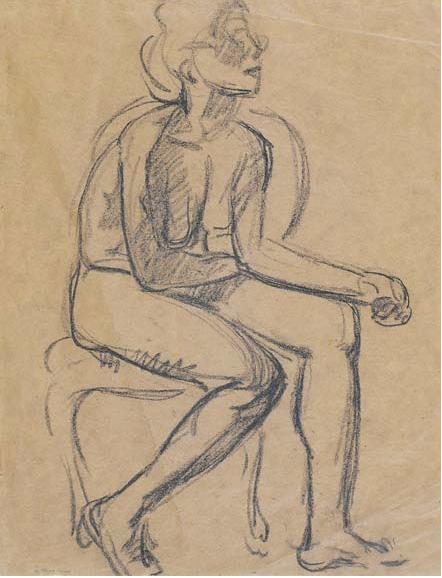Creating a background setting for this scene. In the background, you could imagine a cozy and cluttered artist's studio. Perhaps there is a large, worn wooden table covered with drawing utensils, paint brushes, and half-finished sketches. The walls might be adorned with various artworks and inspirational quotes. A soft, warm light filters through a window, illuminating dust particles dancing in the air. There could be an antique bookshelf filled with classic literature and art history books. This setting paints a picture of a serene and thoughtful space, dedicated to creativity and introspection. How can the background setting change the perception of the figure? A detailed background setting can add depth to the perception of the figure by providing context to their contemplative state. In an artist's studio, the figure might be seen as an art model, deeply immersed in a pose during a drawing session. The creative chaos and the tools around indicate a space where art is born, suggesting the figure's role in the creative process. Conversely, if the background were an empty, minimalist room, the focus would solely be on the figure's introspection, emphasizing solitude and personal thought. The setting can shift the narrative from a collaborative artistic endeavor to an individual’s reflective moment. 